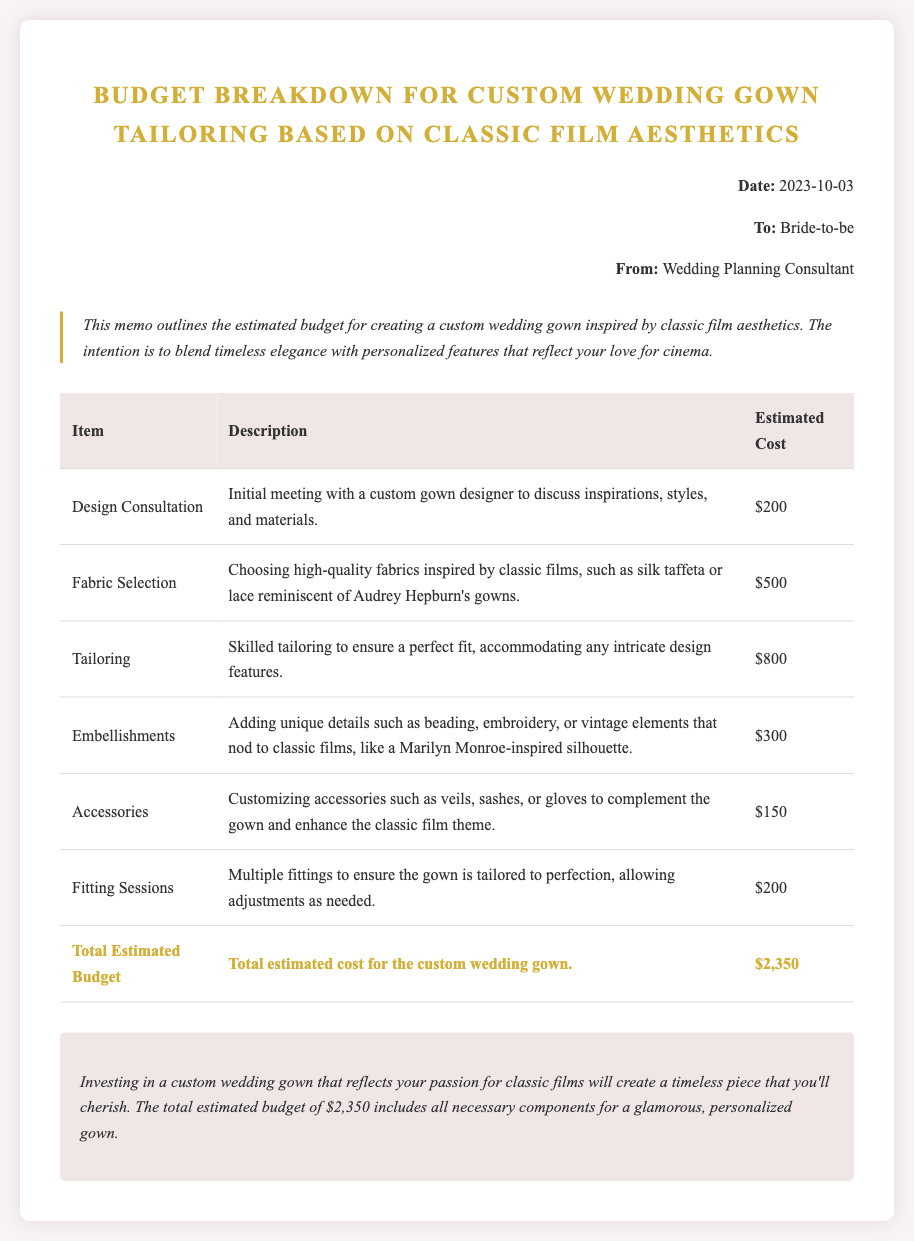What is the date of the memo? The date of the memo is stated at the top of the document.
Answer: 2023-10-03 Who is the memo addressed to? The recipient of the memo is mentioned in the header section.
Answer: Bride-to-be What is the estimated cost for fabric selection? The estimated cost for fabric selection is outlined in the table.
Answer: $500 What style is mentioned for embellishments? The style mentioned for embellishments relates to a specific classic film star's silhouette.
Answer: Marilyn Monroe-inspired What is the total estimated budget? The total estimated budget is provided as a summary at the end of the cost table.
Answer: $2,350 What is included in the design consultation? The design consultation includes discussion of inspirations, styles, and materials.
Answer: Initial meeting with a custom gown designer How many fitting sessions are included in the budget? The number of fitting sessions is mentioned in one of the table entries.
Answer: Multiple What is the purpose of the memo? The purpose of the memo is stated in the introductory paragraph.
Answer: Outline estimated budget for creating a custom wedding gown What aesthetic is the custom gown based on? The aesthetic for the custom gown is described at the beginning of the document.
Answer: Classic film aesthetics 